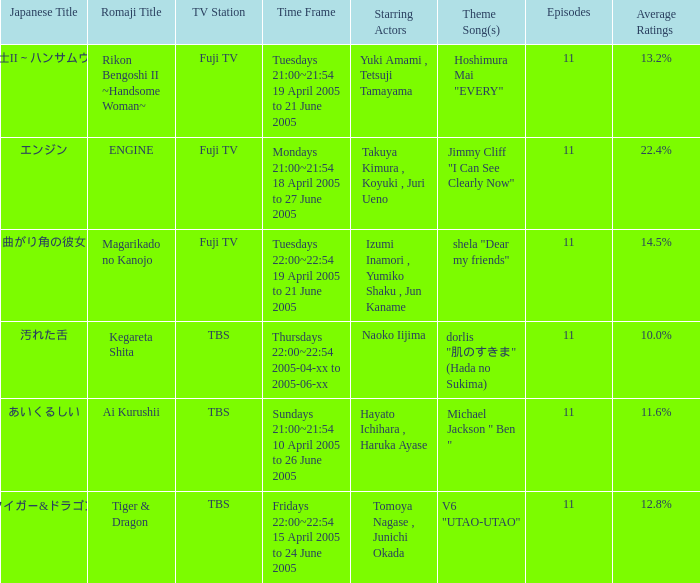What is maximum number of episodes for a show? 11.0. 